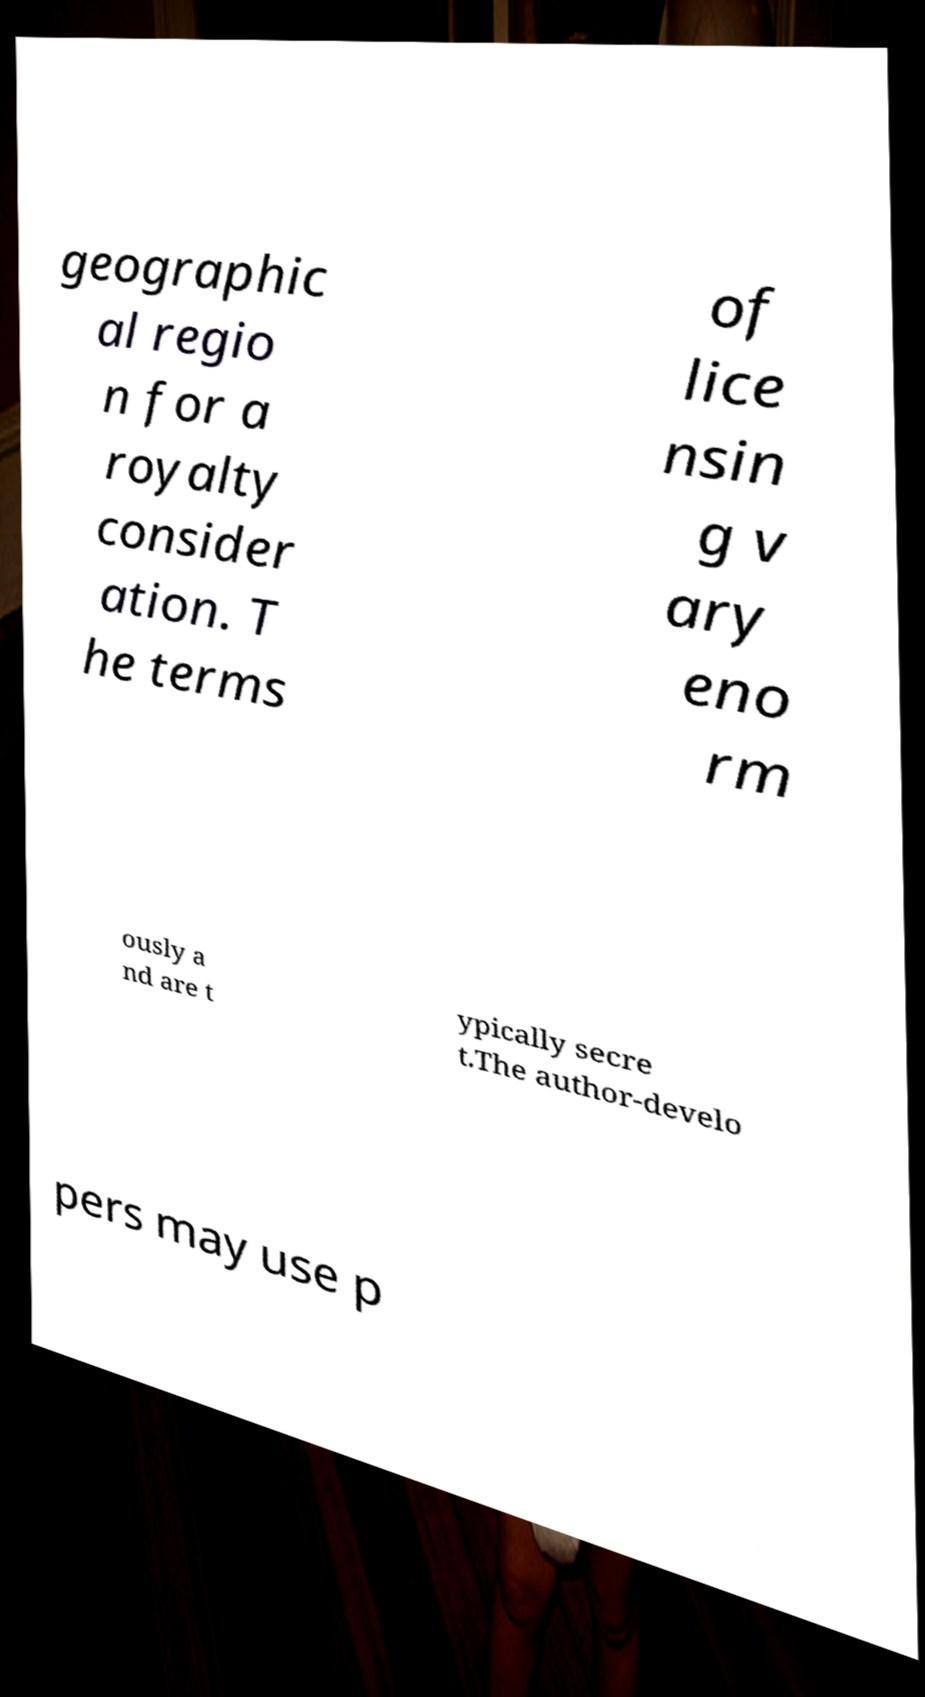I need the written content from this picture converted into text. Can you do that? geographic al regio n for a royalty consider ation. T he terms of lice nsin g v ary eno rm ously a nd are t ypically secre t.The author-develo pers may use p 